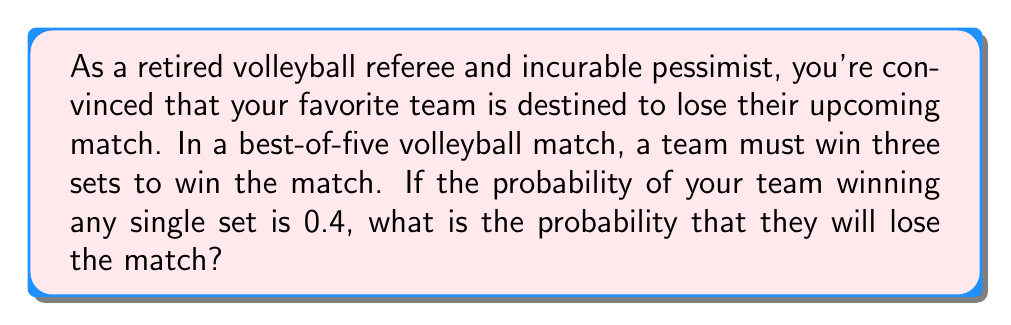Show me your answer to this math problem. Let's approach this step-by-step:

1) First, we need to identify all the ways the team can lose the match. They can lose in:
   - 3 sets (3-0)
   - 4 sets (3-1)
   - 5 sets (3-2)

2) Let's calculate the probability of each scenario:

   a) Losing in 3 sets (3-0):
      Probability = $0.6^3 = 0.216$

   b) Losing in 4 sets (3-1):
      Probability = $\binom{4}{1} \cdot 0.4^1 \cdot 0.6^3 = 4 \cdot 0.4 \cdot 0.216 = 0.3456$

   c) Losing in 5 sets (3-2):
      Probability = $\binom{5}{2} \cdot 0.4^2 \cdot 0.6^3 = 10 \cdot 0.16 \cdot 0.216 = 0.3456$

3) The total probability of losing the match is the sum of these probabilities:

   $$P(\text{losing}) = 0.216 + 0.3456 + 0.3456 = 0.9072$$

4) We can verify this result by calculating the probability of winning the match and subtracting from 1:

   $$P(\text{winning}) = 1 - P(\text{losing}) = 1 - 0.9072 = 0.0928$$

   This matches the probability of winning at least 3 out of 5 sets with a 0.4 probability of winning each set.
Answer: The probability that the team will lose the match is 0.9072 or approximately 90.72%. 